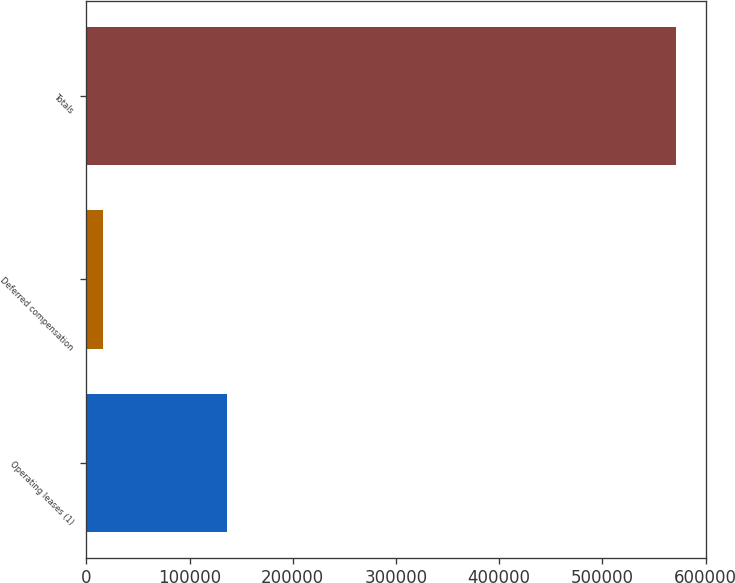<chart> <loc_0><loc_0><loc_500><loc_500><bar_chart><fcel>Operating leases (1)<fcel>Deferred compensation<fcel>Totals<nl><fcel>136484<fcel>16537<fcel>571577<nl></chart> 